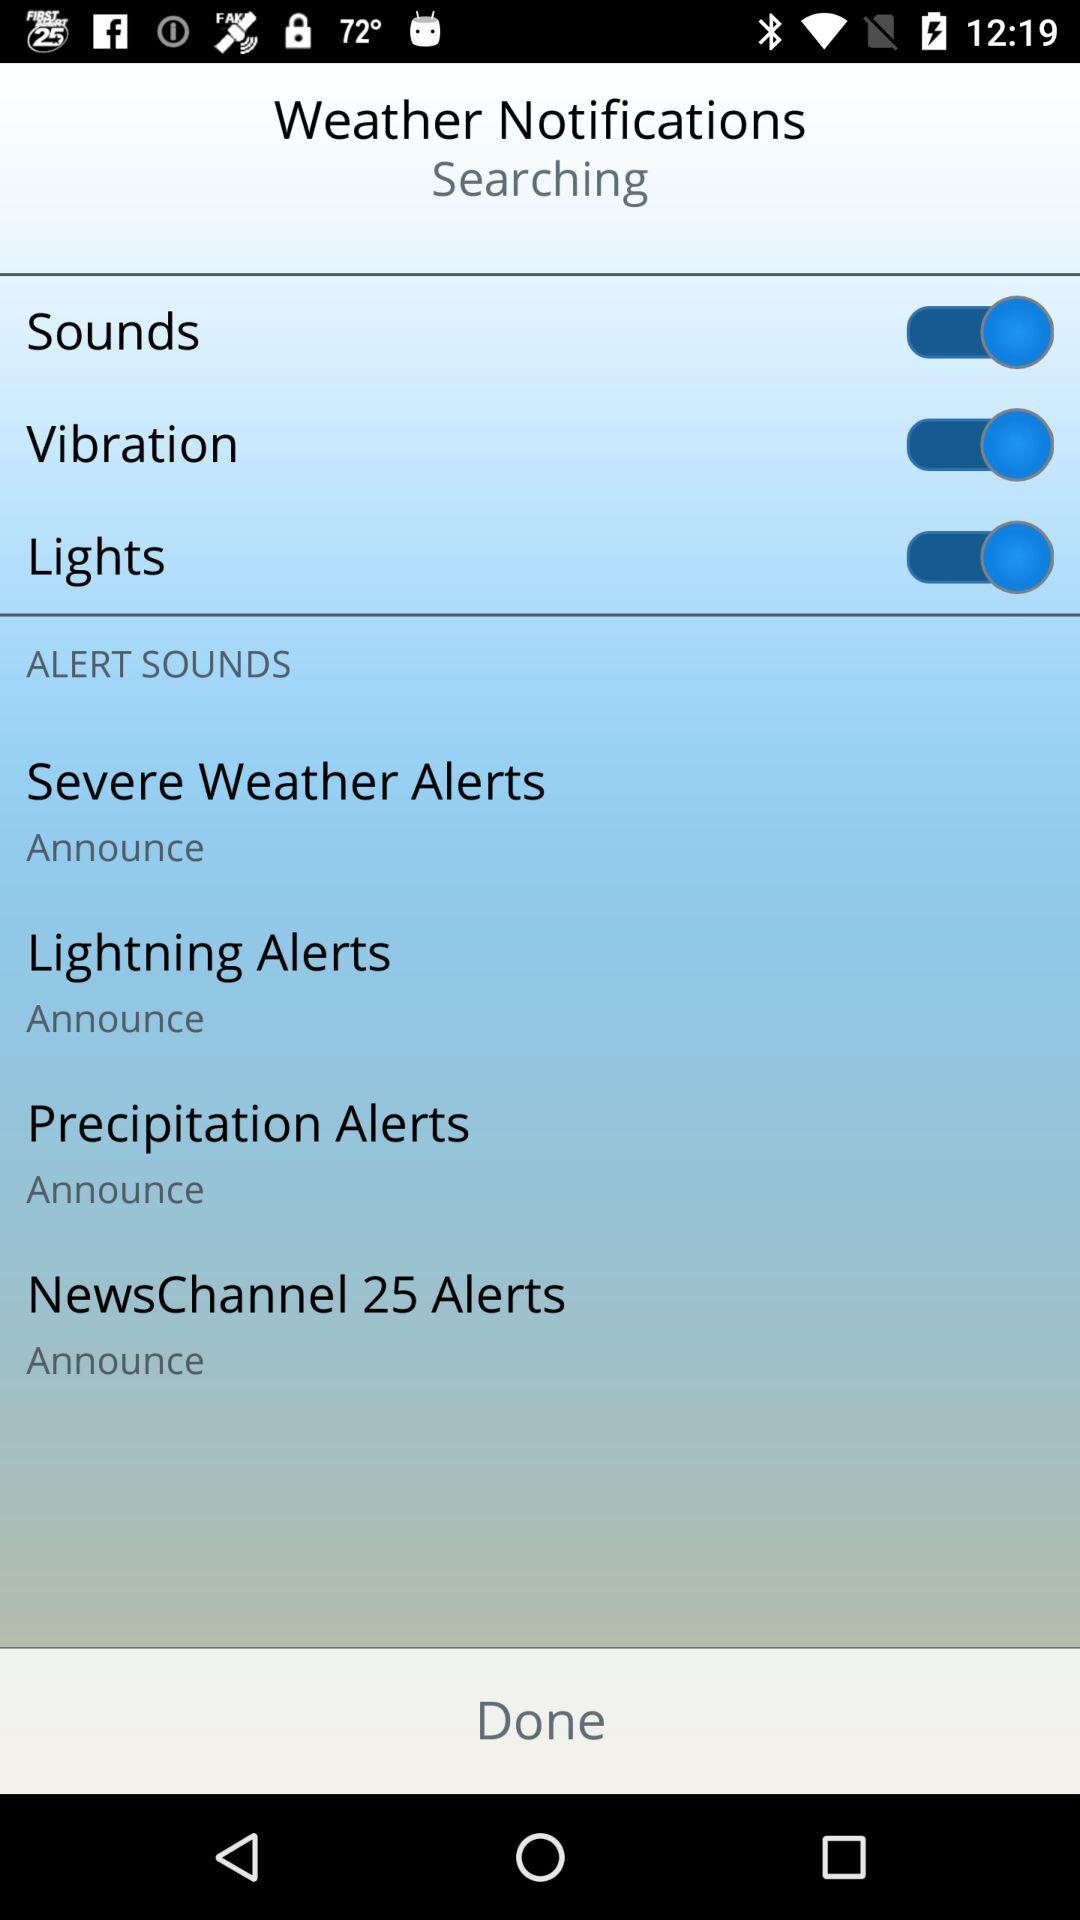How many alert sounds are there?
Answer the question using a single word or phrase. 4 